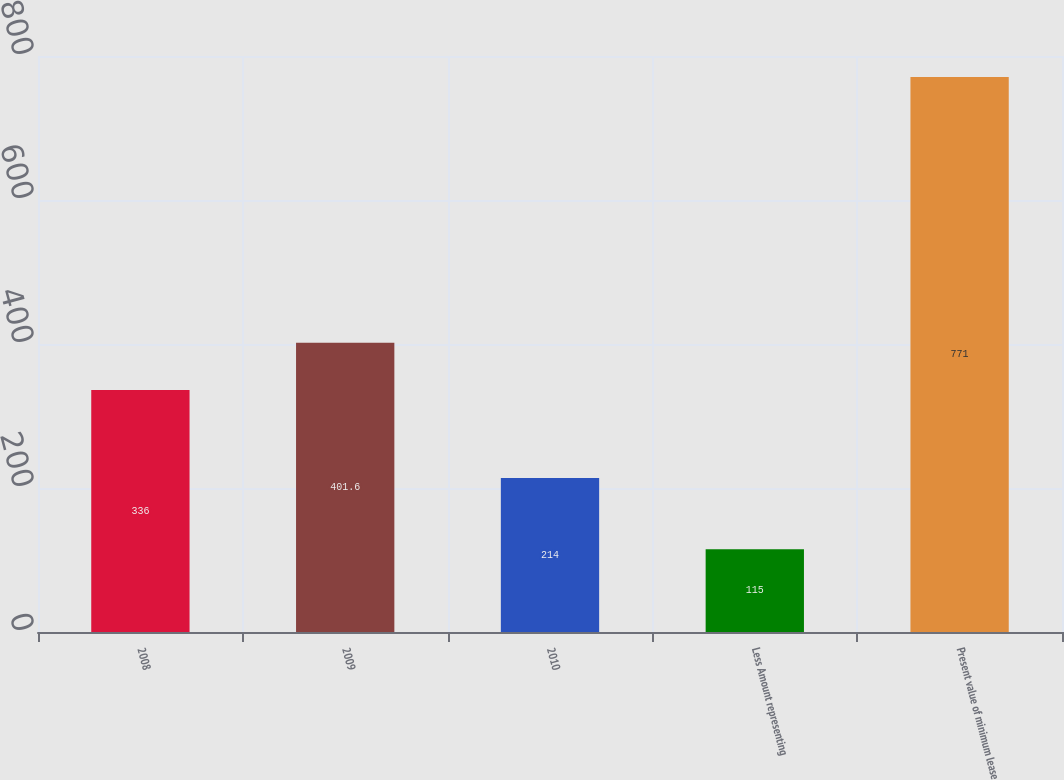<chart> <loc_0><loc_0><loc_500><loc_500><bar_chart><fcel>2008<fcel>2009<fcel>2010<fcel>Less Amount representing<fcel>Present value of minimum lease<nl><fcel>336<fcel>401.6<fcel>214<fcel>115<fcel>771<nl></chart> 